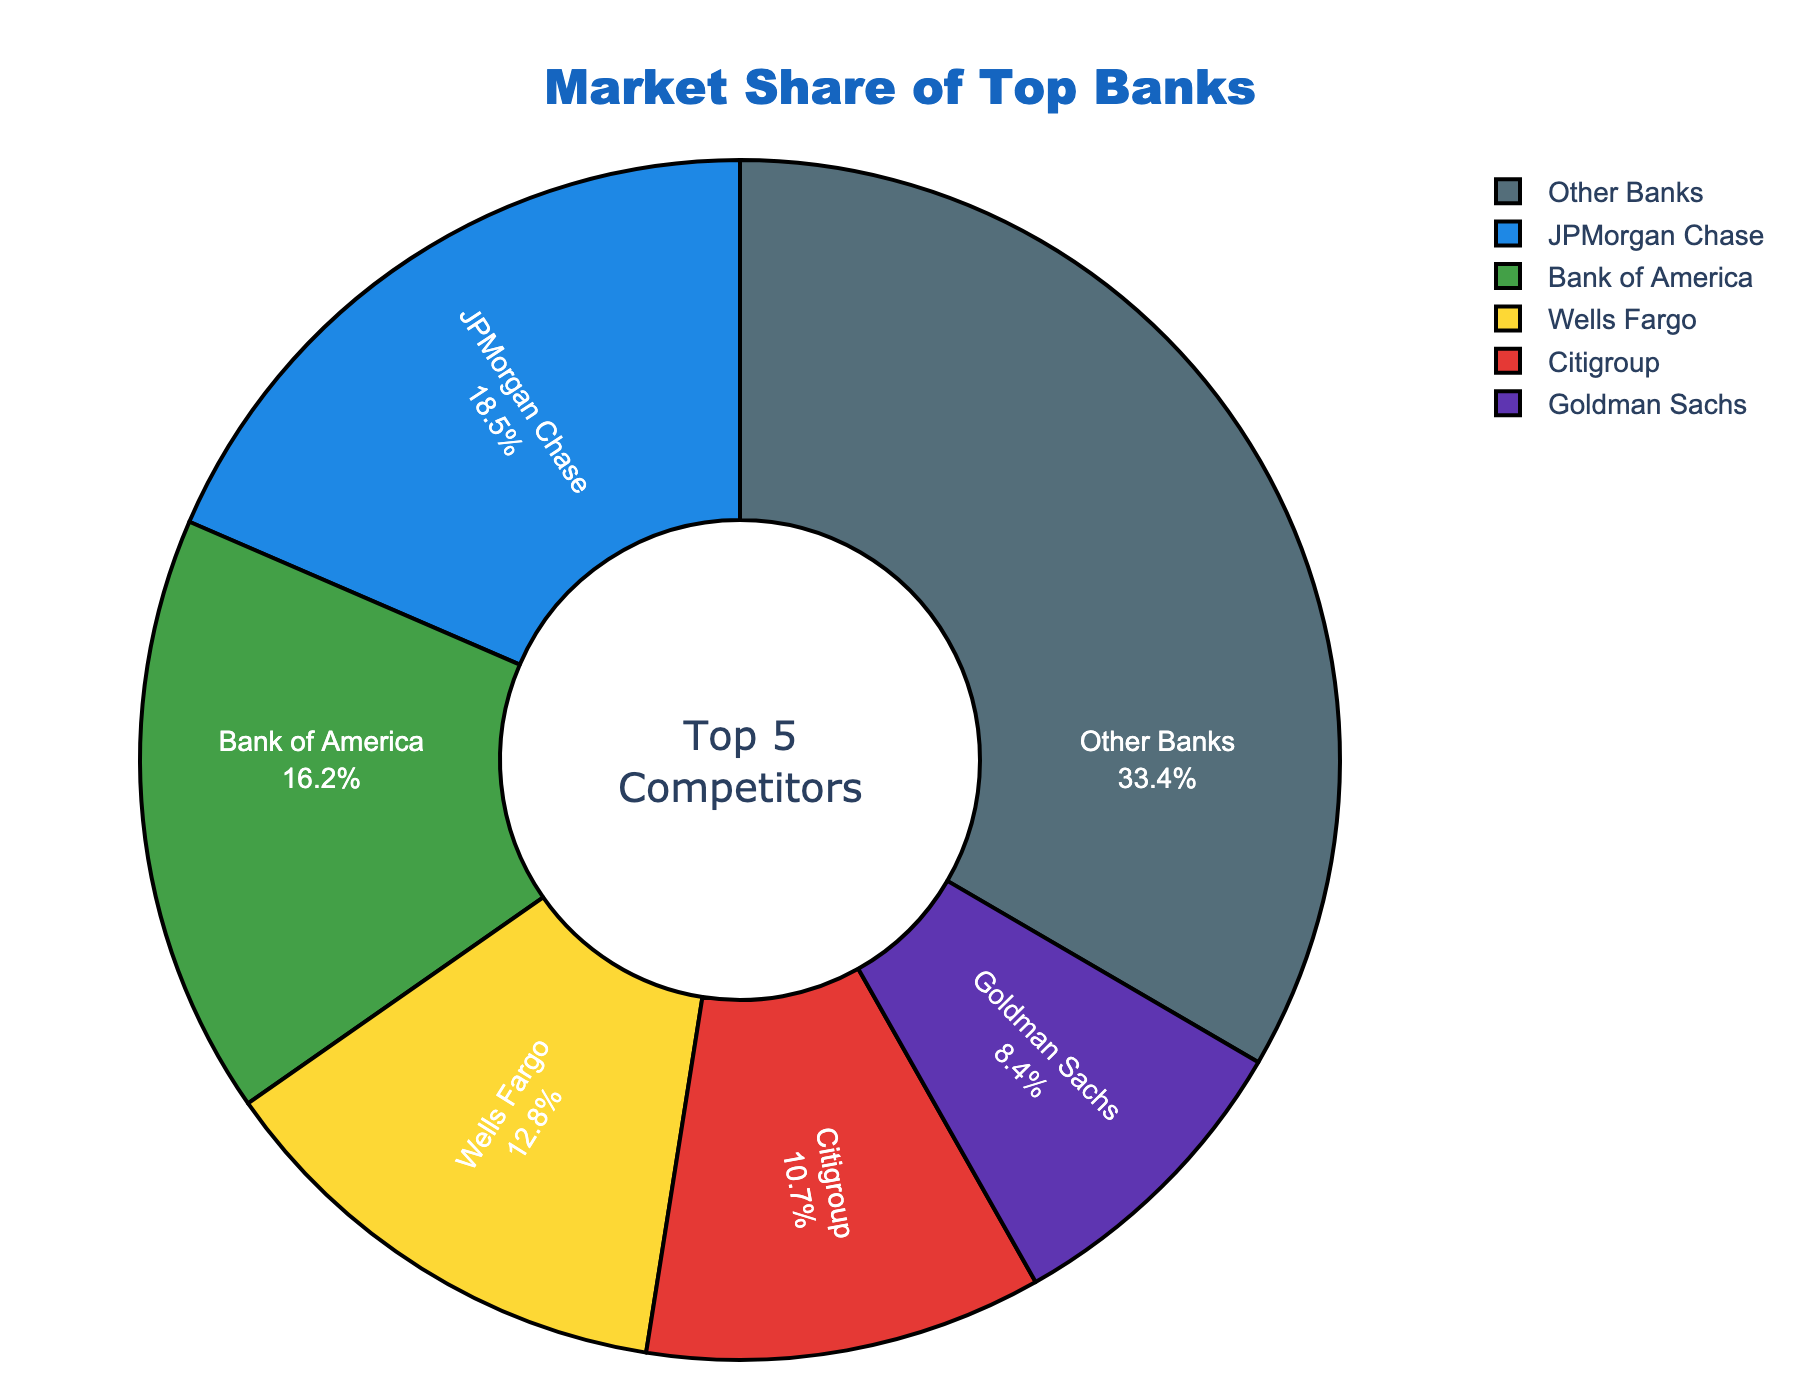Which company has the largest market share? The pie chart shows that JPMorgan Chase has the largest market share.
Answer: JPMorgan Chase Which company has the smallest market share among the top 5 companies? The pie chart shows that Goldman Sachs has the smallest market share among the top 5 companies.
Answer: Goldman Sachs What is the combined market share of Bank of America and Wells Fargo? Bank of America has a market share of 16.2% and Wells Fargo has 12.8%. Adding these together gives 29%.
Answer: 29% How does Wells Fargo's market share compare to Citigroup's market share? Wells Fargo has a market share of 12.8%, while Citigroup has a market share of 10.7%. Therefore, Wells Fargo has a larger market share than Citigroup.
Answer: Wells Fargo has a larger market share What is the market share difference between the company with the highest and the company with the lowest market share among the top 5? The largest market share is JPMorgan Chase with 18.5% and the smallest is Goldman Sachs with 8.4%. The difference is 18.5% - 8.4% = 10.1%.
Answer: 10.1% What percentage of the market share do the top 5 companies combined hold? Summing the market shares of the top 5 companies: 18.5% + 16.2% + 12.8% + 10.7% + 8.4% = 66.6%.
Answer: 66.6% Which company or companies are represented by the green and blue sections in the pie chart? The pie chart shows Bank of America in green and JPMorgan Chase in blue.
Answer: Bank of America and JPMorgan Chase How much more market share does JPMorgan Chase have compared to Goldman Sachs? JPMorgan Chase has 18.5%, and Goldman Sachs has 8.4%. So, 18.5% - 8.4% = 10.1% more.
Answer: 10.1% What portions of the chart are labeled with percent values? All sections of the pie chart are labeled with percent values, representing the market share each company holds.
Answer: All sections How much market share do companies other than the top 5 hold? Other Banks hold 33.4% market share as shown in the pie chart.
Answer: 33.4% 